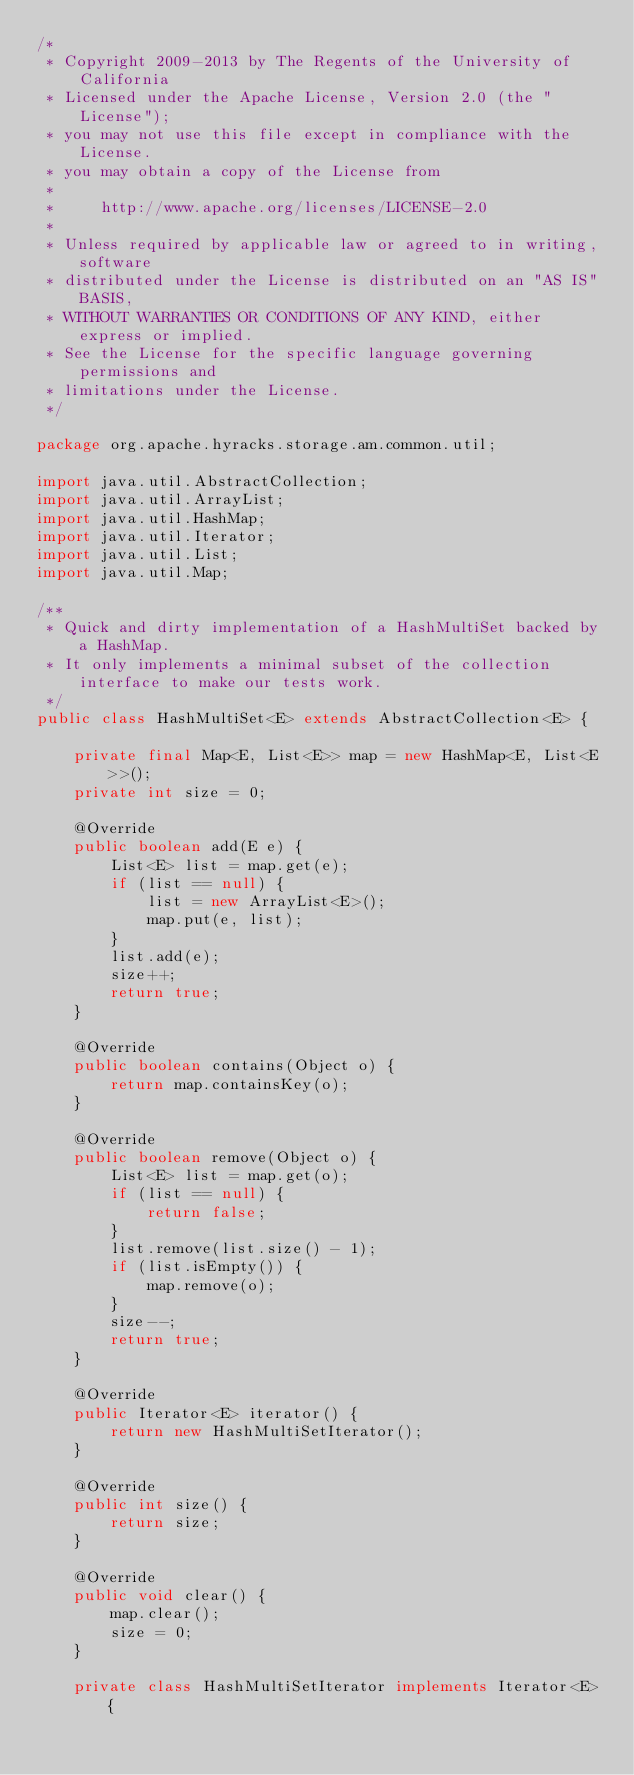<code> <loc_0><loc_0><loc_500><loc_500><_Java_>/*
 * Copyright 2009-2013 by The Regents of the University of California
 * Licensed under the Apache License, Version 2.0 (the "License");
 * you may not use this file except in compliance with the License.
 * you may obtain a copy of the License from
 * 
 *     http://www.apache.org/licenses/LICENSE-2.0
 * 
 * Unless required by applicable law or agreed to in writing, software
 * distributed under the License is distributed on an "AS IS" BASIS,
 * WITHOUT WARRANTIES OR CONDITIONS OF ANY KIND, either express or implied.
 * See the License for the specific language governing permissions and
 * limitations under the License.
 */

package org.apache.hyracks.storage.am.common.util;

import java.util.AbstractCollection;
import java.util.ArrayList;
import java.util.HashMap;
import java.util.Iterator;
import java.util.List;
import java.util.Map;

/**
 * Quick and dirty implementation of a HashMultiSet backed by a HashMap.
 * It only implements a minimal subset of the collection interface to make our tests work.
 */
public class HashMultiSet<E> extends AbstractCollection<E> {

    private final Map<E, List<E>> map = new HashMap<E, List<E>>(); 
    private int size = 0;
    
    @Override
    public boolean add(E e) {
        List<E> list = map.get(e);
        if (list == null) {
            list = new ArrayList<E>();
            map.put(e, list);
        }
        list.add(e);
        size++;
        return true;
    }
    
    @Override
    public boolean contains(Object o) {
        return map.containsKey(o);
    }
    
    @Override
    public boolean remove(Object o) {
        List<E> list = map.get(o);
        if (list == null) {
            return false;            
        }
        list.remove(list.size() - 1);
        if (list.isEmpty()) {
            map.remove(o);
        }
        size--;
        return true;
    }
    
    @Override
    public Iterator<E> iterator() {
        return new HashMultiSetIterator();
    }

    @Override
    public int size() {
        return size;
    }
    
    @Override
    public void clear() {
        map.clear();
        size = 0;
    }
    
    private class HashMultiSetIterator implements Iterator<E> {
</code> 